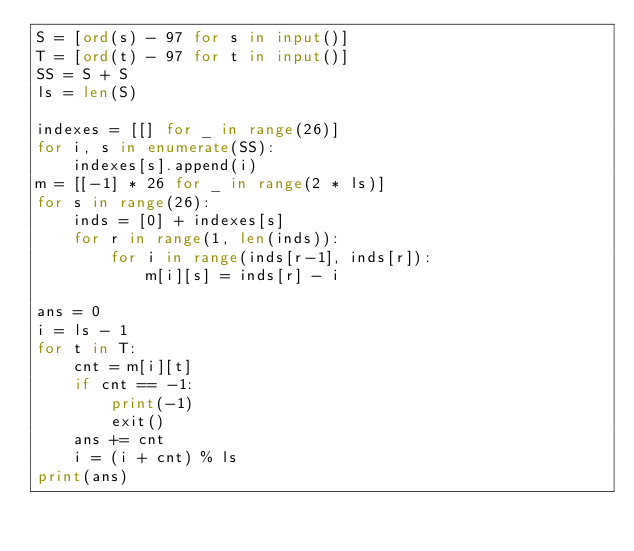<code> <loc_0><loc_0><loc_500><loc_500><_Python_>S = [ord(s) - 97 for s in input()]
T = [ord(t) - 97 for t in input()]
SS = S + S
ls = len(S)

indexes = [[] for _ in range(26)]
for i, s in enumerate(SS):
    indexes[s].append(i)
m = [[-1] * 26 for _ in range(2 * ls)]
for s in range(26):
    inds = [0] + indexes[s]
    for r in range(1, len(inds)):
        for i in range(inds[r-1], inds[r]):
            m[i][s] = inds[r] - i

ans = 0
i = ls - 1
for t in T:
    cnt = m[i][t]
    if cnt == -1:
        print(-1)
        exit()
    ans += cnt
    i = (i + cnt) % ls
print(ans)
</code> 